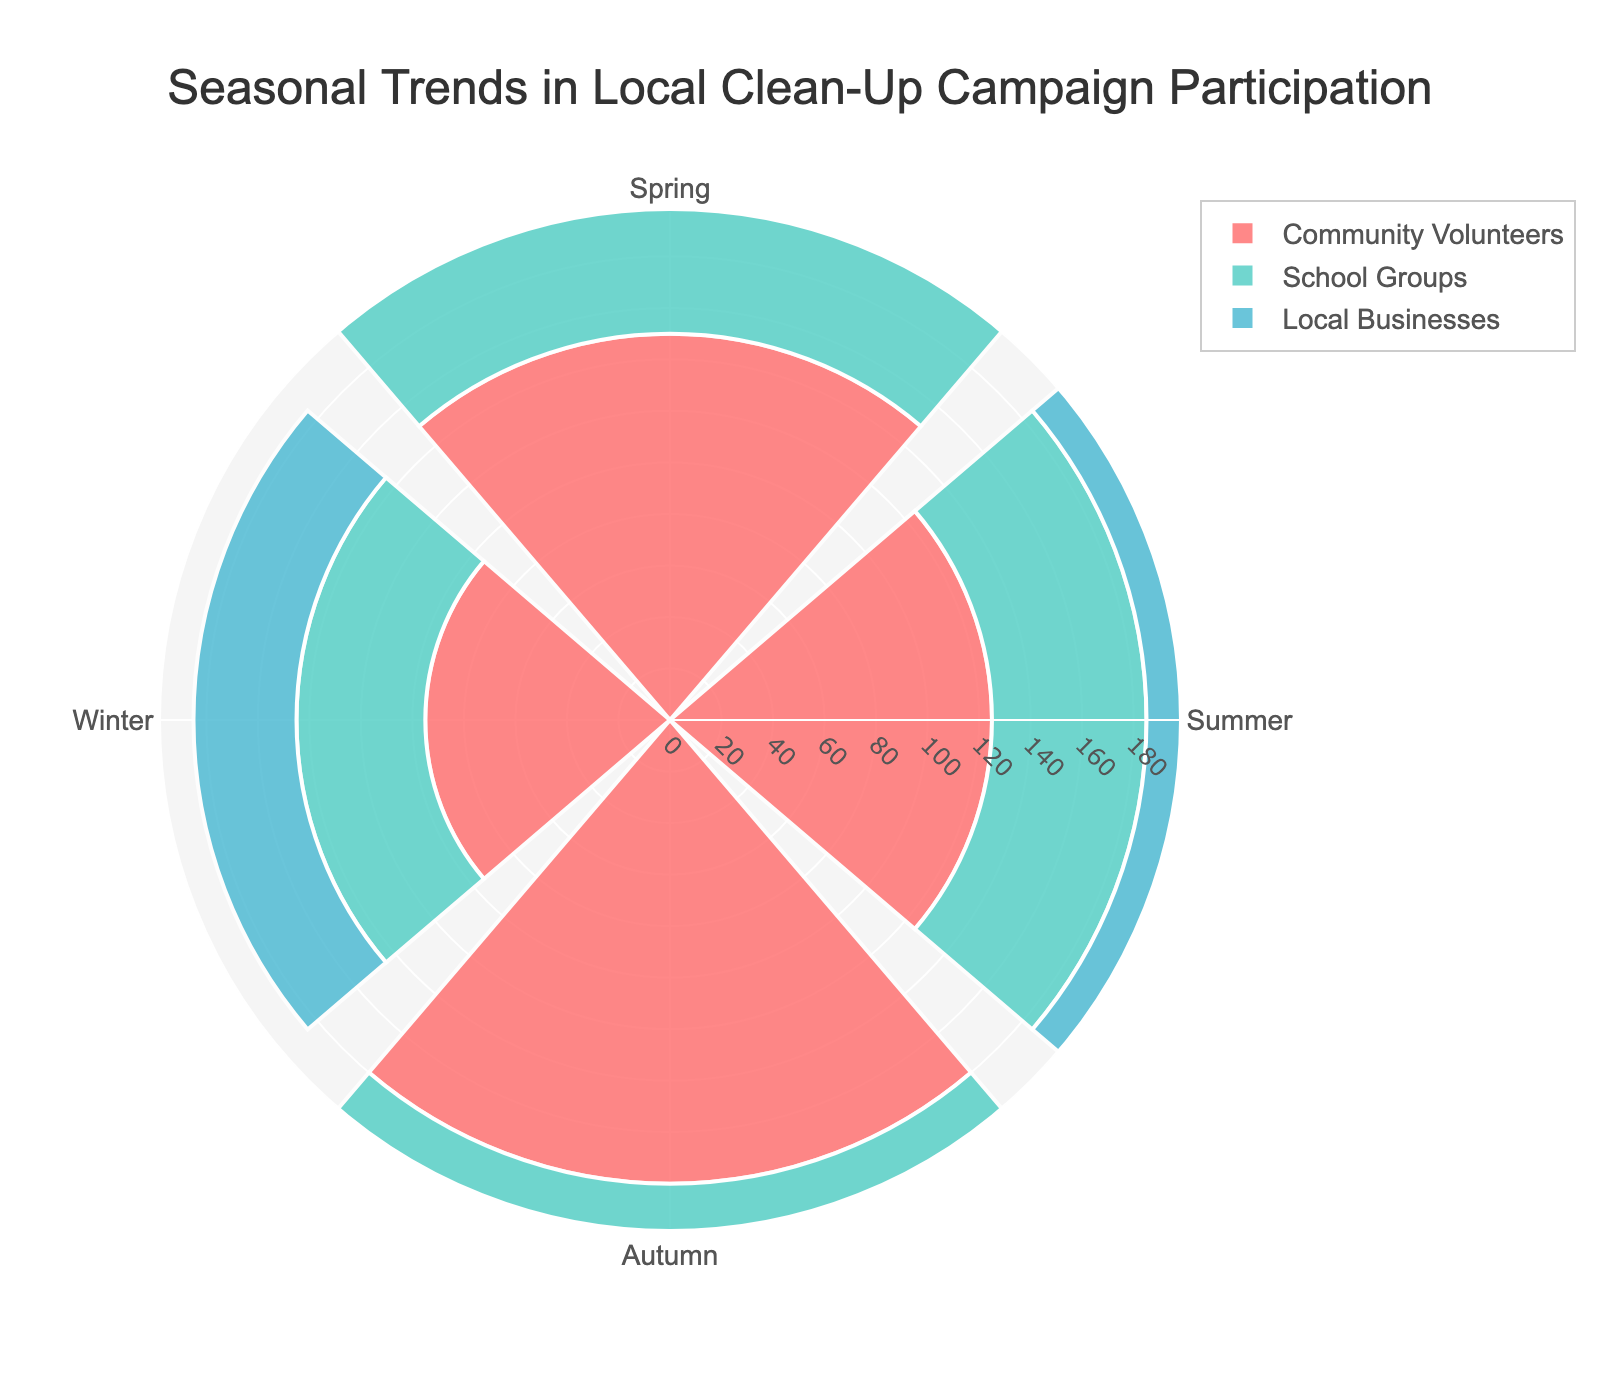What is the title of the figure? The title is located at the top of the figure and is clearly displayed in larger font. It provides context about what the figure represents.
Answer: Seasonal Trends in Local Clean-Up Campaign Participation How many groups are represented in the rose chart? By observing the color legend, there are three distinct colors indicating the three groups.
Answer: 3 Which season has the highest participation from Community Volunteers? The segment with the longest radius for Community Volunteers, represented by the corresponding color, should be identified. The longest radius appears in autumn.
Answer: Autumn Which group had the lowest participation in winter? Look for the smallest radius in the winter section of the chart. Local Businesses have the shortest segment in the winter.
Answer: Local Businesses What is the combined participation of all groups in summer? Sum the participation values for all groups in summer: Community Volunteers (125), School Groups (60), and Local Businesses (55). 125 + 60 + 55 = 240
Answer: 240 During which season is the participation from Local Businesses highest? Find the season where the Local Businesses' segment has the largest radius. This happens in autumn.
Answer: Autumn Which group shows the smallest variation in participation throughout the seasons? Calculate the range (max - min) for each group across all seasons. Community Volunteers: 180 - 95 = 85; School Groups: 90 - 50 = 40; Local Businesses: 80 - 40 = 40. Both School Groups and Local Businesses show the smallest variation.
Answer: School Groups and Local Businesses How does spring participation from School Groups compare to winter participation from Local Businesses? Compare the radius lengths or values directly in the corresponding segments. Spring participation from School Groups is 85, while winter participation from Local Businesses is 40. 85 is greater than 40.
Answer: Greater What is the average participation of Community Volunteers across all seasons? Sum the participation of Community Volunteers across all seasons and divide by the number of seasons: (150 + 125 + 180 + 95) / 4 = 137.5
Answer: 137.5 Which season has the highest overall participation when combining all groups? Sum the participation values for all groups in each season and then compare them: Spring (305), Summer (240), Autumn (350), Winter (185). Autumn has the highest total.
Answer: Autumn 